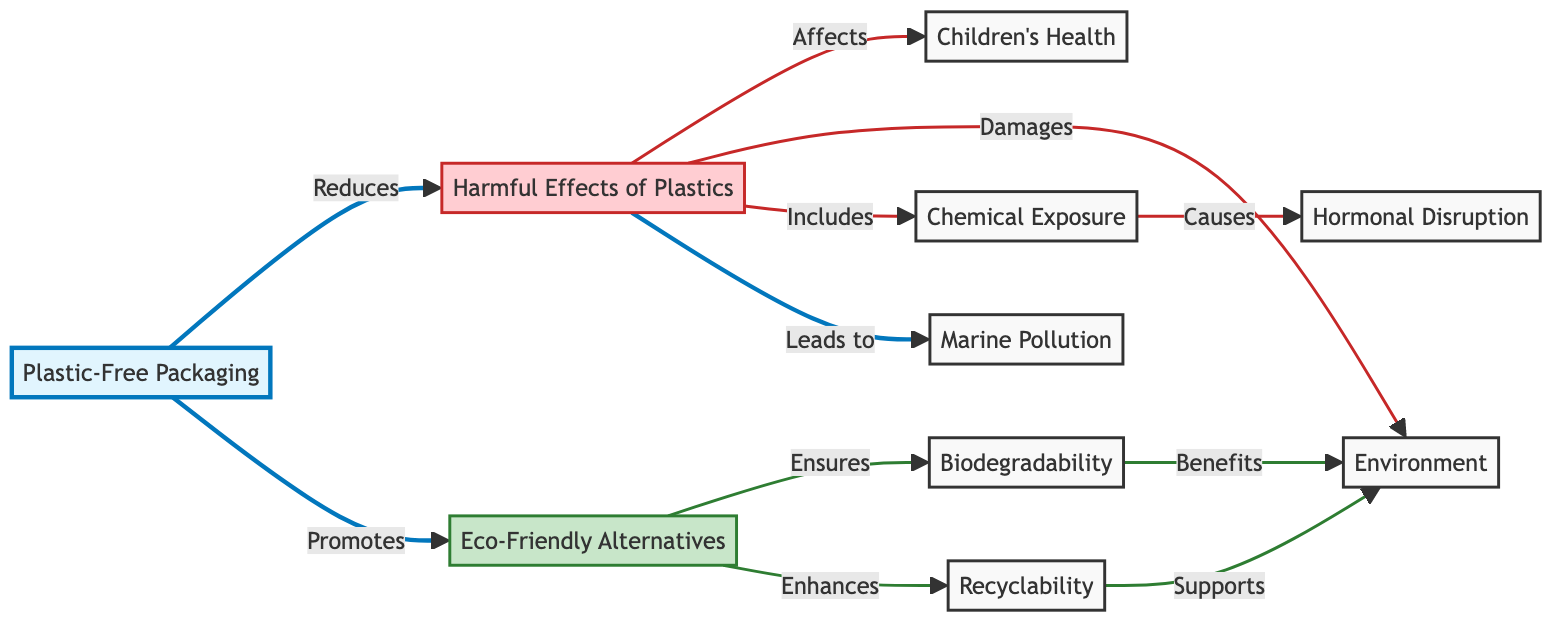What does PFP promote? The diagram clearly shows that "Plastic-Free Packaging" (PFP) promotes "Eco-Friendly Alternatives" (A). This relationship is a direct line from PFP to A indicating a supportive connection between these two nodes.
Answer: Eco-Friendly Alternatives How many harmful effects of plastics are listed? In the diagram, three specific harmful effects of plastics are indicated: "Chemical Exposure," "Hormonal Disruption," and "Marine Pollution." Counting these gives a total of three effects.
Answer: 3 What does "Chemical Exposure" cause? The diagram indicates that "Chemical Exposure" (CE) leads to "Hormonal Disruption" (HD), which is shown through the direct connection from CE to HD.
Answer: Hormonal Disruption How does "Plastic-Free Packaging" affect the environment? The diagram illustrates that "Plastic-Free Packaging" reduces the harmful effects of plastics (PH), which damages the environment (E). There’s a line connecting PH to E clearly indicating this leading relationship.
Answer: Damages What benefits does biodegradability bring? According to the diagram, "Biodegradability" (B) benefits the environment (E) directly, shown by the link from B to E.
Answer: Benefits What are the two enhancements provided by eco-friendly alternatives? The diagram shows that "Eco-Friendly Alternatives" (A) ensures "Biodegradability" (B) and enhances "Recyclability" (R). These two terms are directly linked to A, indicating their improvement attributes.
Answer: Biodegradability, Recyclability Which aspect includes marine pollution? In the diagram, "Marine Pollution" (MP) is listed as an effect under the node "Harmful Effects of Plastics" (PH). This is emphasized through a direct linkage indicating it as part of the overall harmful effects section.
Answer: Harmful Effects of Plastics Which effect of plastics relates to chemical exposure? The diagram illustrates that "Chemical Exposure" (CE) is under "Harmful Effects of Plastics" (PH), which shows that chemical exposure is specifically a part of or related to these harmful effects.
Answer: Harmful Effects of Plastics 